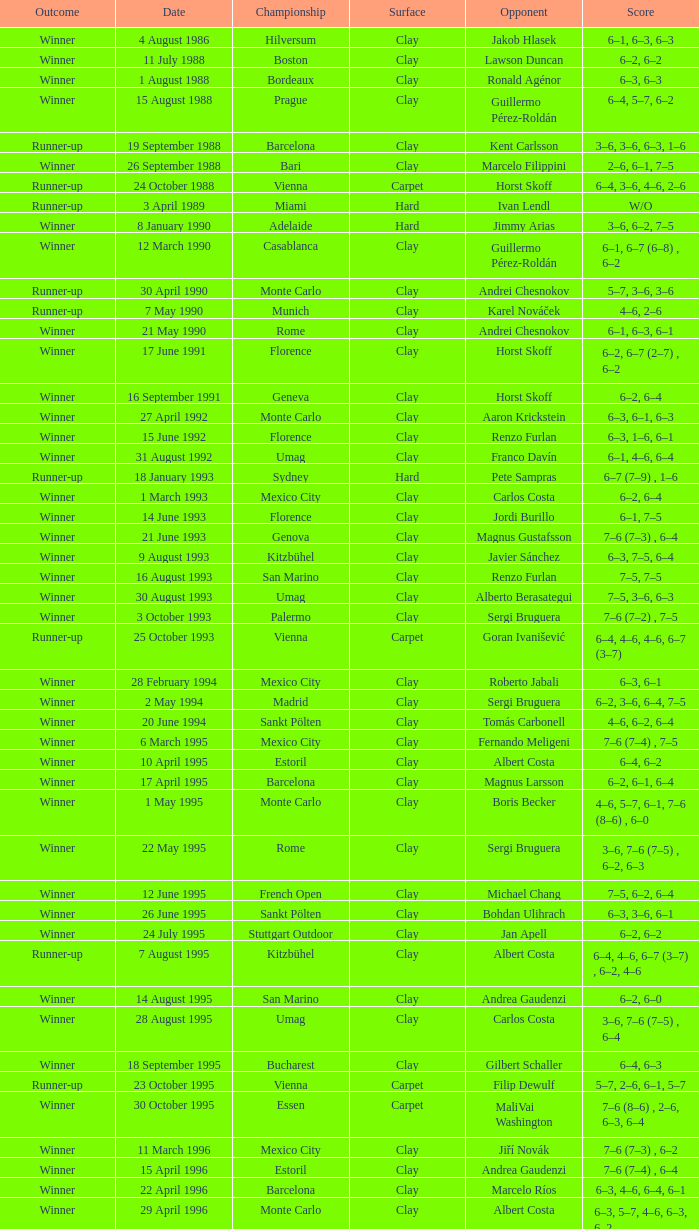Who is the opponent on 18 january 1993? Pete Sampras. 